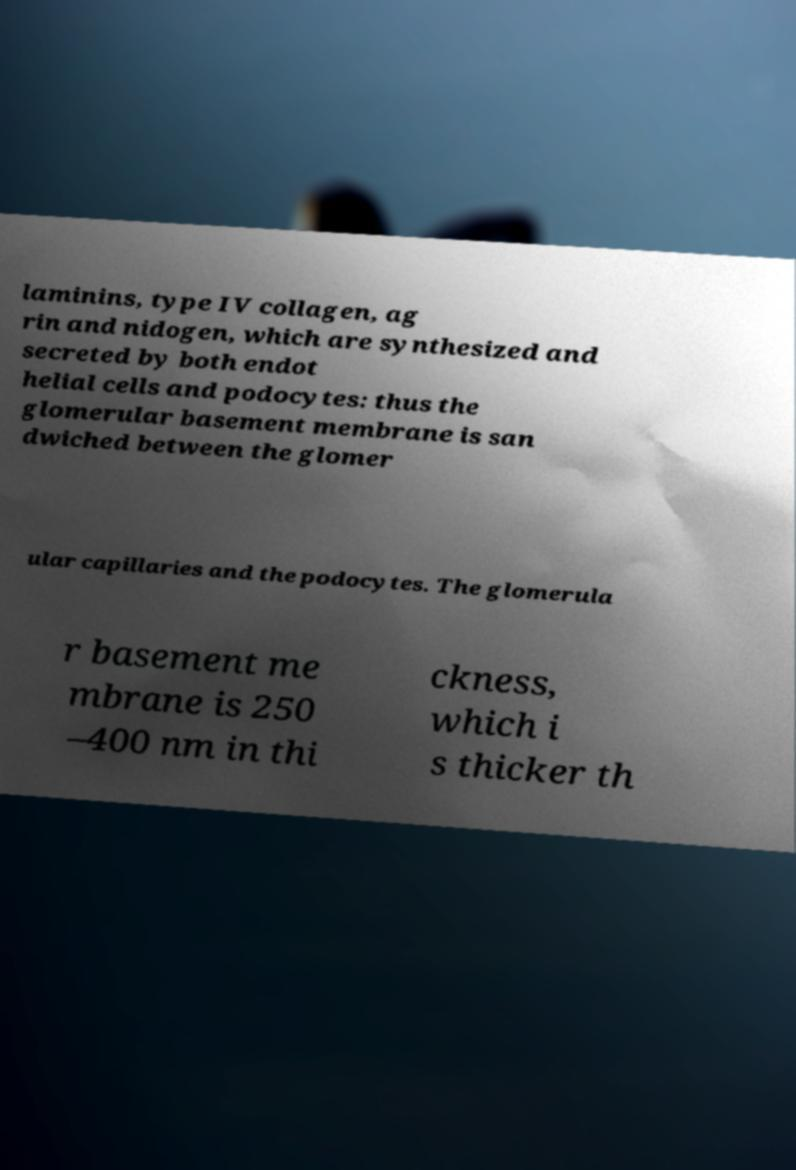What messages or text are displayed in this image? I need them in a readable, typed format. laminins, type IV collagen, ag rin and nidogen, which are synthesized and secreted by both endot helial cells and podocytes: thus the glomerular basement membrane is san dwiched between the glomer ular capillaries and the podocytes. The glomerula r basement me mbrane is 250 –400 nm in thi ckness, which i s thicker th 